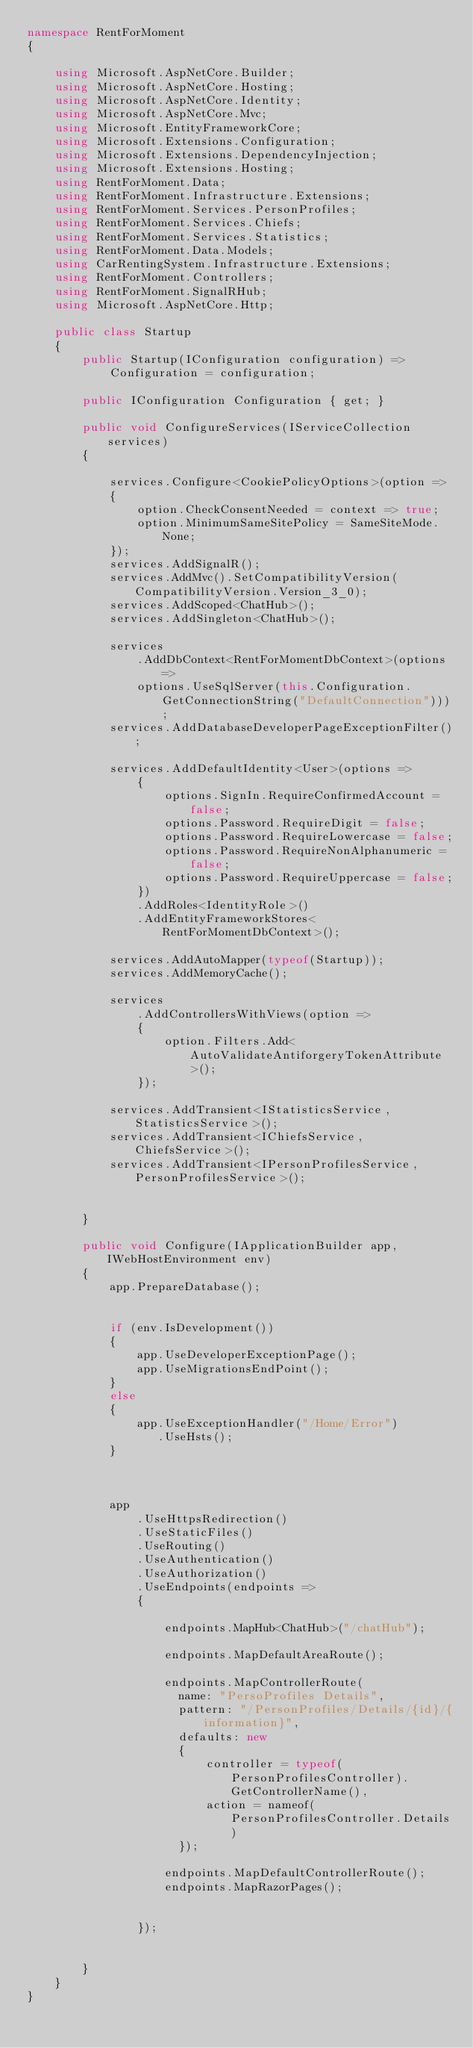<code> <loc_0><loc_0><loc_500><loc_500><_C#_>namespace RentForMoment
{

    using Microsoft.AspNetCore.Builder;
    using Microsoft.AspNetCore.Hosting;
    using Microsoft.AspNetCore.Identity;
    using Microsoft.AspNetCore.Mvc;
    using Microsoft.EntityFrameworkCore;
    using Microsoft.Extensions.Configuration;
    using Microsoft.Extensions.DependencyInjection;
    using Microsoft.Extensions.Hosting;
    using RentForMoment.Data;
    using RentForMoment.Infrastructure.Extensions;
    using RentForMoment.Services.PersonProfiles;
    using RentForMoment.Services.Chiefs;
    using RentForMoment.Services.Statistics;
    using RentForMoment.Data.Models;
    using CarRentingSystem.Infrastructure.Extensions;
    using RentForMoment.Controllers;
    using RentForMoment.SignalRHub;
    using Microsoft.AspNetCore.Http;

    public class Startup
    {
        public Startup(IConfiguration configuration) =>
            Configuration = configuration;

        public IConfiguration Configuration { get; }

        public void ConfigureServices(IServiceCollection services)
        {

            services.Configure<CookiePolicyOptions>(option => 
            {
                option.CheckConsentNeeded = context => true;
                option.MinimumSameSitePolicy = SameSiteMode.None;
            });
            services.AddSignalR();
            services.AddMvc().SetCompatibilityVersion(CompatibilityVersion.Version_3_0);
            services.AddScoped<ChatHub>();
            services.AddSingleton<ChatHub>();

            services
                .AddDbContext<RentForMomentDbContext>(options =>
                options.UseSqlServer(this.Configuration.GetConnectionString("DefaultConnection")));
            services.AddDatabaseDeveloperPageExceptionFilter();

            services.AddDefaultIdentity<User>(options =>
                {
                    options.SignIn.RequireConfirmedAccount = false;
                    options.Password.RequireDigit = false;
                    options.Password.RequireLowercase = false;
                    options.Password.RequireNonAlphanumeric = false;
                    options.Password.RequireUppercase = false;
                })
                .AddRoles<IdentityRole>()
                .AddEntityFrameworkStores<RentForMomentDbContext>();

            services.AddAutoMapper(typeof(Startup));
            services.AddMemoryCache();

            services
                .AddControllersWithViews(option => 
                {
                    option.Filters.Add<AutoValidateAntiforgeryTokenAttribute>();
                });

            services.AddTransient<IStatisticsService, StatisticsService>();
            services.AddTransient<IChiefsService, ChiefsService>();
            services.AddTransient<IPersonProfilesService, PersonProfilesService>();


        }

        public void Configure(IApplicationBuilder app, IWebHostEnvironment env)
        {
            app.PrepareDatabase();
            

            if (env.IsDevelopment())
            {
                app.UseDeveloperExceptionPage();
                app.UseMigrationsEndPoint();
            }
            else
            {
                app.UseExceptionHandler("/Home/Error")
                   .UseHsts();
            }

            

            app
                .UseHttpsRedirection()
                .UseStaticFiles()
                .UseRouting()
                .UseAuthentication()
                .UseAuthorization()
                .UseEndpoints(endpoints =>
                {

                    endpoints.MapHub<ChatHub>("/chatHub");

                    endpoints.MapDefaultAreaRoute();

                    endpoints.MapControllerRoute(
                      name: "PersoProfiles Details",
                      pattern: "/PersonProfiles/Details/{id}/{information}",
                      defaults: new
                      {
                          controller = typeof(PersonProfilesController).GetControllerName(),
                          action = nameof(PersonProfilesController.Details)
                      });

                    endpoints.MapDefaultControllerRoute();
                    endpoints.MapRazorPages();

                    
                });

            
        }
    }
}
</code> 